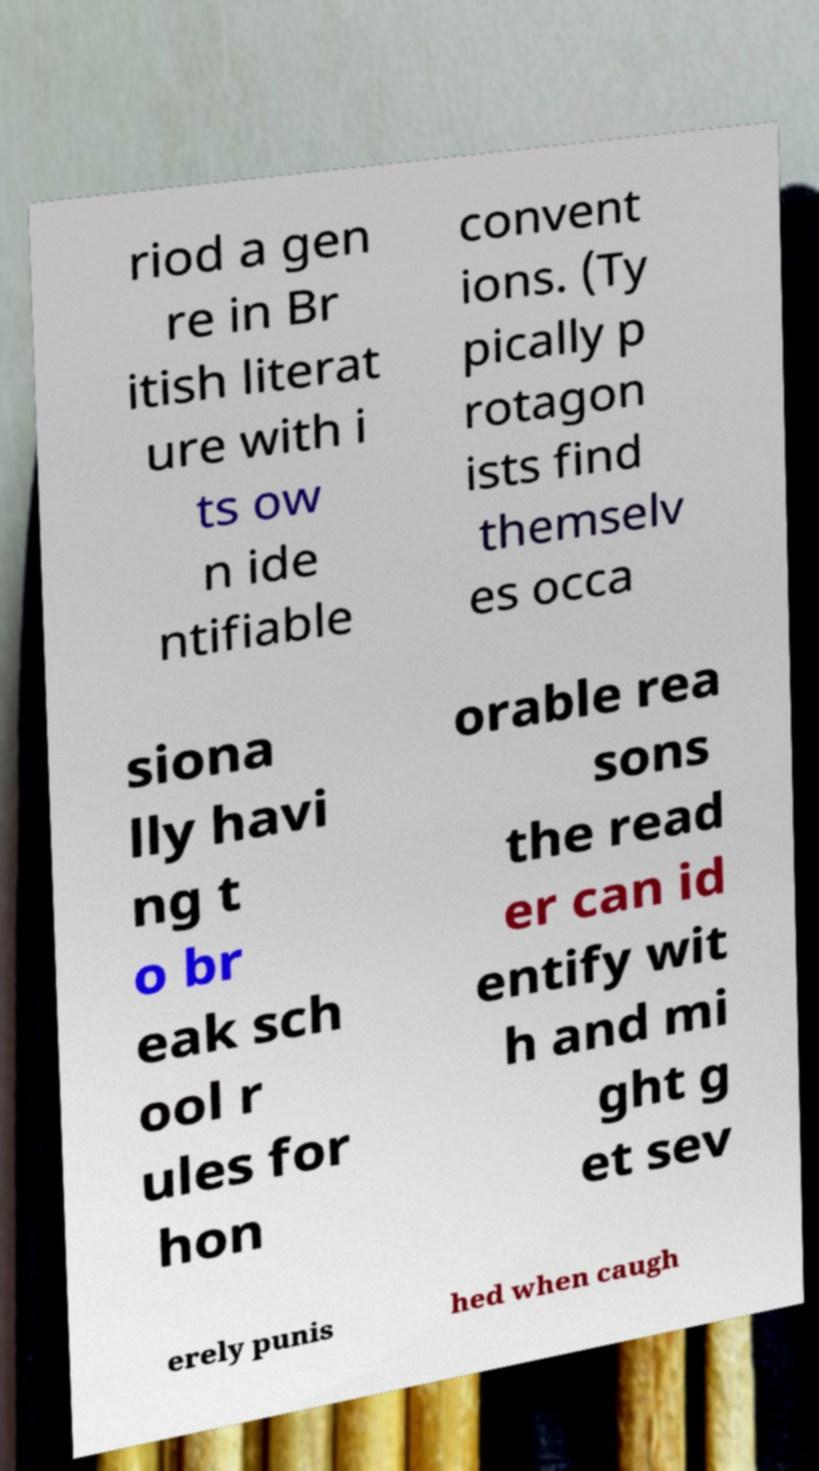Can you read and provide the text displayed in the image?This photo seems to have some interesting text. Can you extract and type it out for me? riod a gen re in Br itish literat ure with i ts ow n ide ntifiable convent ions. (Ty pically p rotagon ists find themselv es occa siona lly havi ng t o br eak sch ool r ules for hon orable rea sons the read er can id entify wit h and mi ght g et sev erely punis hed when caugh 